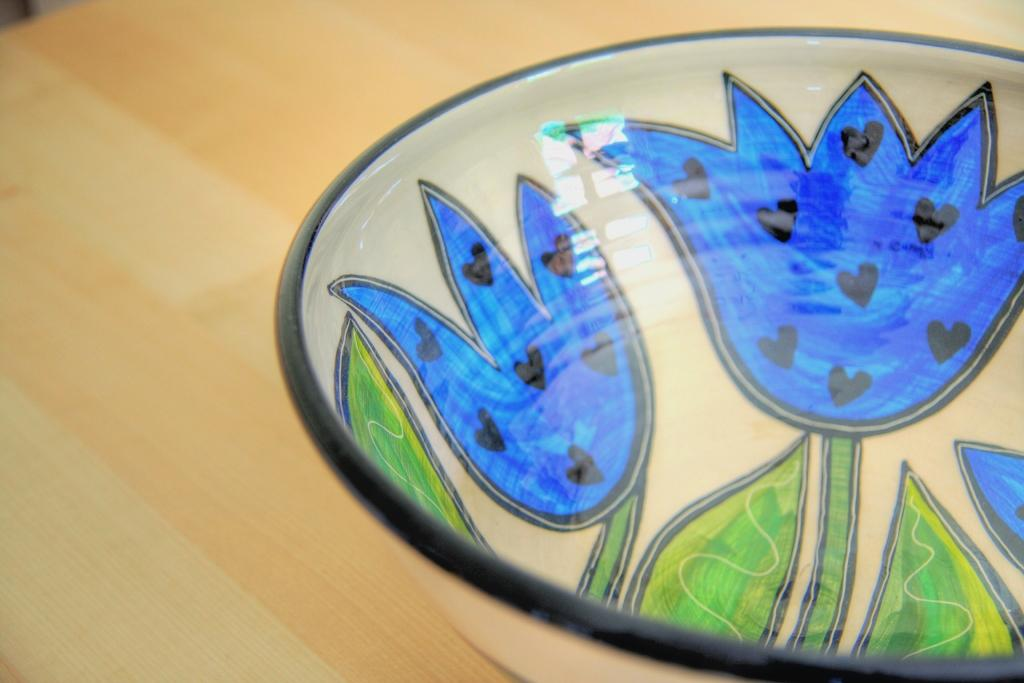What is located on the table in the image? There is a bowl in the image. Can you describe the appearance of the bowl? The bowl has designs on it. Where is the bowl placed in the image? The bowl is placed on a table. How many legs does the bowl have in the image? The bowl does not have legs; it is placed on a table. What is the bowl's reaction to being an afterthought in the image? The bowl is not an afterthought in the image, and therefore it does not have any reaction. 